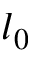Convert formula to latex. <formula><loc_0><loc_0><loc_500><loc_500>l _ { 0 }</formula> 